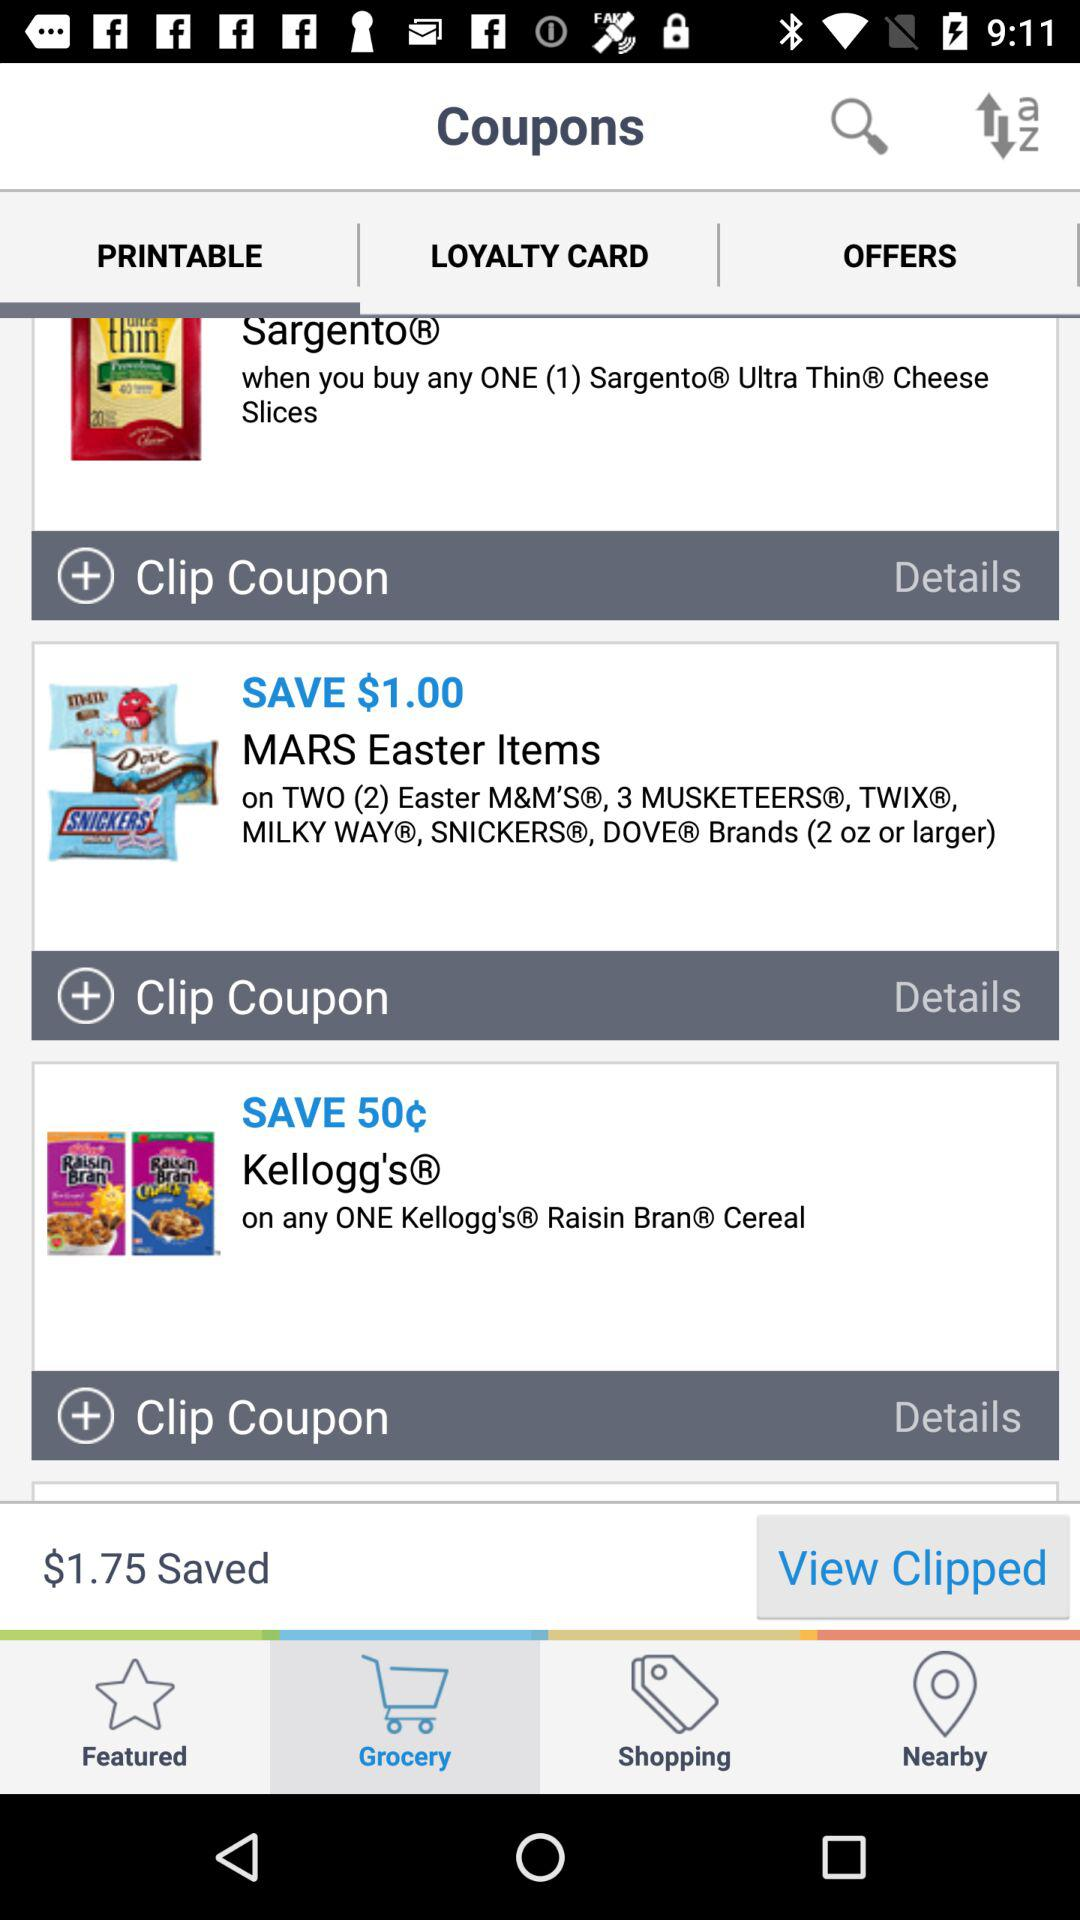How much money can be saved on "MARS Easter" items? The money that can be saved on "MARS Easter" items is $1. 